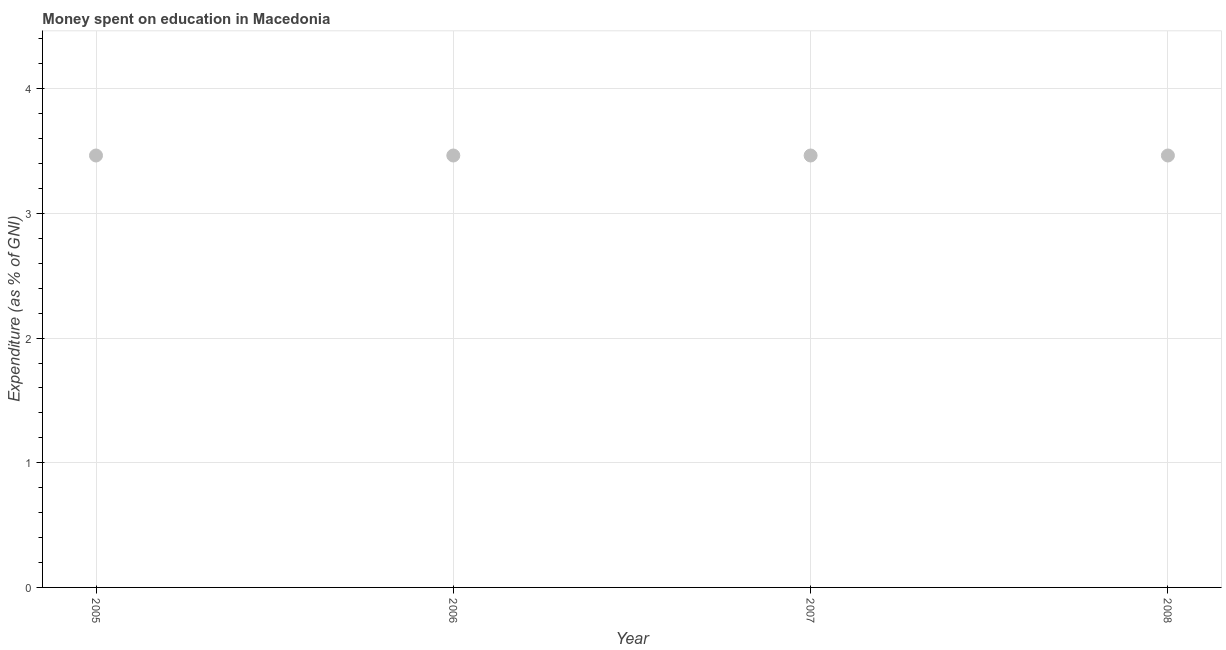What is the expenditure on education in 2008?
Give a very brief answer. 3.46. Across all years, what is the maximum expenditure on education?
Give a very brief answer. 3.46. Across all years, what is the minimum expenditure on education?
Your answer should be compact. 3.46. What is the sum of the expenditure on education?
Your answer should be compact. 13.86. What is the average expenditure on education per year?
Give a very brief answer. 3.46. What is the median expenditure on education?
Offer a very short reply. 3.46. Do a majority of the years between 2006 and 2008 (inclusive) have expenditure on education greater than 4.2 %?
Your response must be concise. No. What is the ratio of the expenditure on education in 2006 to that in 2007?
Offer a very short reply. 1. Is the expenditure on education in 2006 less than that in 2008?
Give a very brief answer. No. What is the difference between the highest and the second highest expenditure on education?
Make the answer very short. 0. In how many years, is the expenditure on education greater than the average expenditure on education taken over all years?
Keep it short and to the point. 0. How many dotlines are there?
Provide a short and direct response. 1. Does the graph contain any zero values?
Your answer should be compact. No. What is the title of the graph?
Offer a terse response. Money spent on education in Macedonia. What is the label or title of the X-axis?
Offer a very short reply. Year. What is the label or title of the Y-axis?
Make the answer very short. Expenditure (as % of GNI). What is the Expenditure (as % of GNI) in 2005?
Your answer should be very brief. 3.46. What is the Expenditure (as % of GNI) in 2006?
Keep it short and to the point. 3.46. What is the Expenditure (as % of GNI) in 2007?
Offer a very short reply. 3.46. What is the Expenditure (as % of GNI) in 2008?
Provide a succinct answer. 3.46. What is the difference between the Expenditure (as % of GNI) in 2005 and 2007?
Keep it short and to the point. 0. What is the difference between the Expenditure (as % of GNI) in 2006 and 2007?
Give a very brief answer. 0. What is the difference between the Expenditure (as % of GNI) in 2006 and 2008?
Provide a short and direct response. 0. What is the difference between the Expenditure (as % of GNI) in 2007 and 2008?
Your answer should be very brief. 0. What is the ratio of the Expenditure (as % of GNI) in 2006 to that in 2007?
Offer a terse response. 1. 